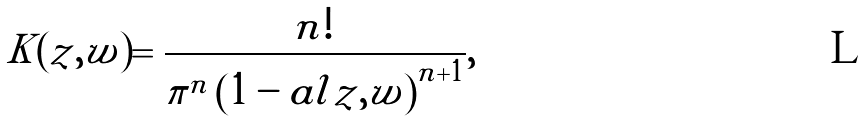<formula> <loc_0><loc_0><loc_500><loc_500>K ( z , w ) = \frac { n ! } { \pi ^ { n } \left ( 1 - a l { z , w } \right ) ^ { n + 1 } } ,</formula> 